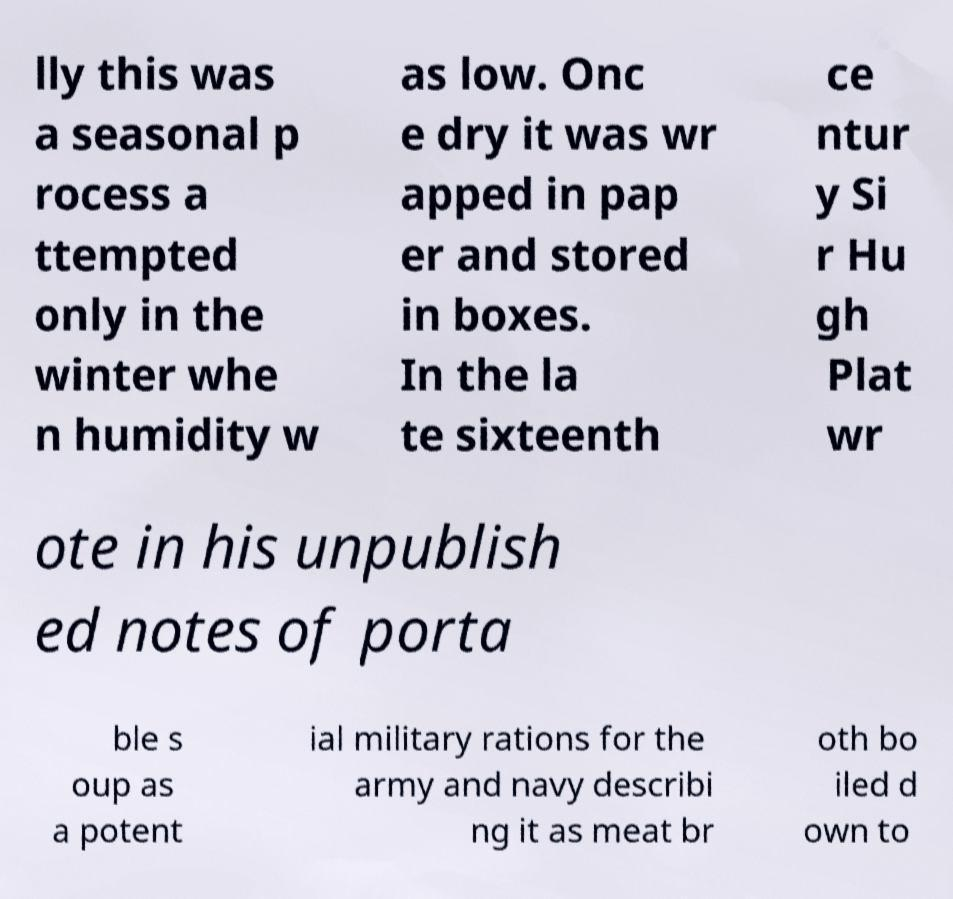What messages or text are displayed in this image? I need them in a readable, typed format. lly this was a seasonal p rocess a ttempted only in the winter whe n humidity w as low. Onc e dry it was wr apped in pap er and stored in boxes. In the la te sixteenth ce ntur y Si r Hu gh Plat wr ote in his unpublish ed notes of porta ble s oup as a potent ial military rations for the army and navy describi ng it as meat br oth bo iled d own to 